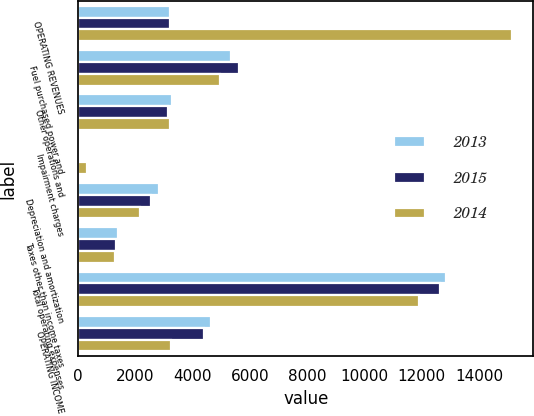Convert chart to OTSL. <chart><loc_0><loc_0><loc_500><loc_500><stacked_bar_chart><ecel><fcel>OPERATING REVENUES<fcel>Fuel purchased power and<fcel>Other operations and<fcel>Impairment charges<fcel>Depreciation and amortization<fcel>Taxes other than income taxes<fcel>Total operating expenses<fcel>OPERATING INCOME<nl><fcel>2013<fcel>3217.5<fcel>5327<fcel>3269<fcel>2<fcel>2831<fcel>1399<fcel>12854<fcel>4632<nl><fcel>2015<fcel>3217.5<fcel>5602<fcel>3149<fcel>11<fcel>2551<fcel>1324<fcel>12637<fcel>4384<nl><fcel>2014<fcel>15136<fcel>4958<fcel>3194<fcel>300<fcel>2163<fcel>1280<fcel>11895<fcel>3241<nl></chart> 